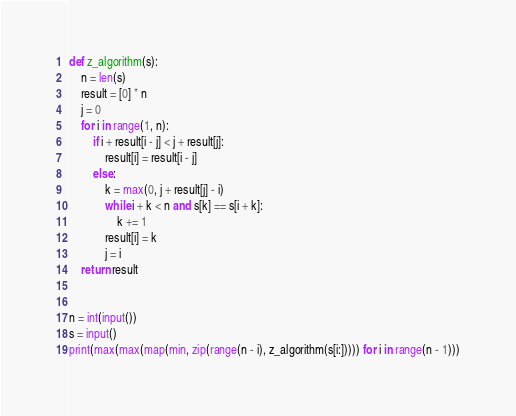Convert code to text. <code><loc_0><loc_0><loc_500><loc_500><_Python_>def z_algorithm(s):
    n = len(s)
    result = [0] * n
    j = 0
    for i in range(1, n):
        if i + result[i - j] < j + result[j]:
            result[i] = result[i - j]
        else:
            k = max(0, j + result[j] - i)
            while i + k < n and s[k] == s[i + k]:
                k += 1
            result[i] = k
            j = i
    return result


n = int(input())
s = input()
print(max(max(map(min, zip(range(n - i), z_algorithm(s[i:])))) for i in range(n - 1)))
</code> 